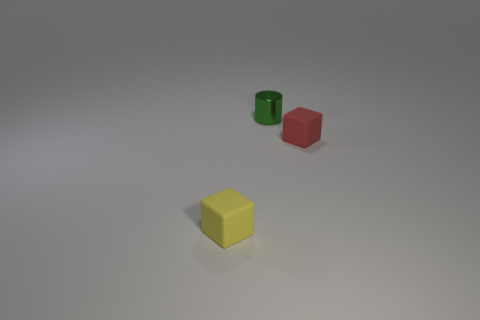Add 3 red things. How many objects exist? 6 Subtract all yellow blocks. How many blocks are left? 1 Subtract all cylinders. How many objects are left? 2 Add 3 red rubber cubes. How many red rubber cubes are left? 4 Add 1 tiny cyan metallic blocks. How many tiny cyan metallic blocks exist? 1 Subtract 0 blue balls. How many objects are left? 3 Subtract 2 blocks. How many blocks are left? 0 Subtract all gray cylinders. Subtract all blue spheres. How many cylinders are left? 1 Subtract all small green metallic things. Subtract all small brown matte cubes. How many objects are left? 2 